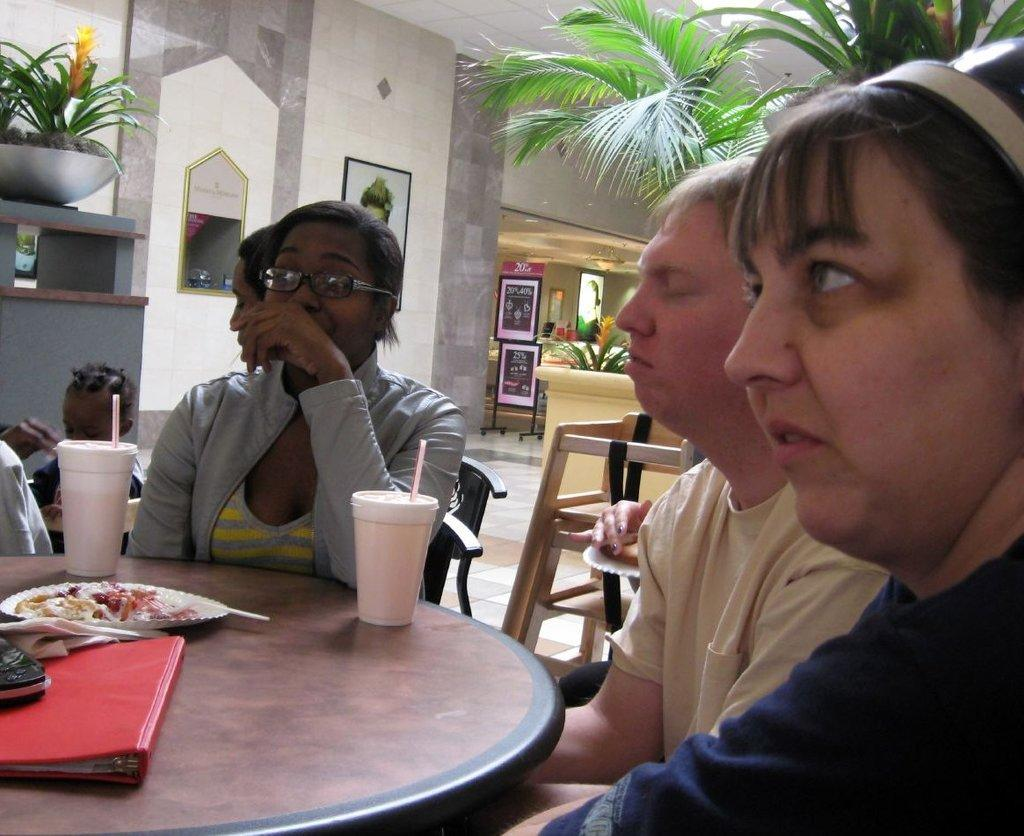What are the people in the image doing? The people in the image are sitting on chairs around a table. How many cups are on the table? There are 2 cups on the table. What else is on the table besides the cups? There is a food item and a book on the table. What can be seen in the background of the image? In the background, there are plants, hoardings, and a wall visible. What type of plant is the carpenter using to apply lipstick in the image? There is no carpenter or lipstick present in the image. 